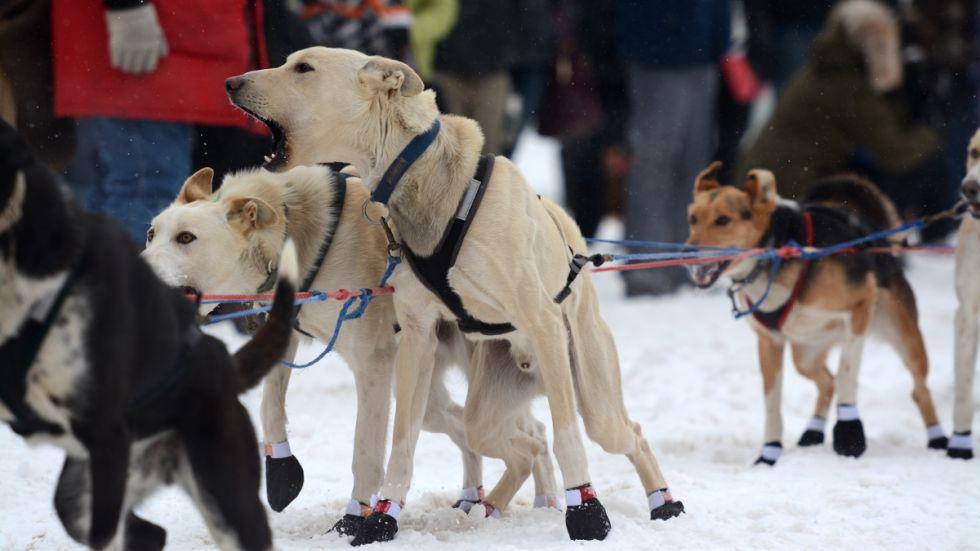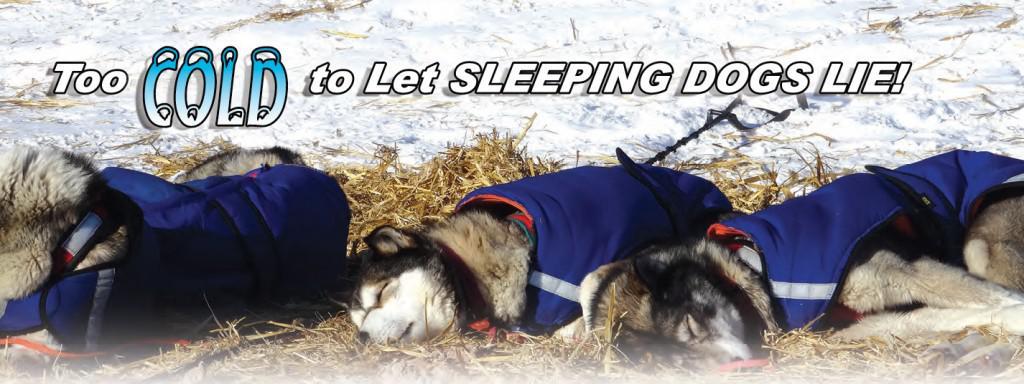The first image is the image on the left, the second image is the image on the right. Assess this claim about the two images: "One image shows a sled dog team with a standing sled driver in back moving across the snow, and the other image features at least one creature standing up on two legs.". Correct or not? Answer yes or no. No. The first image is the image on the left, the second image is the image on the right. Evaluate the accuracy of this statement regarding the images: "Some dogs are wearing booties.". Is it true? Answer yes or no. Yes. 